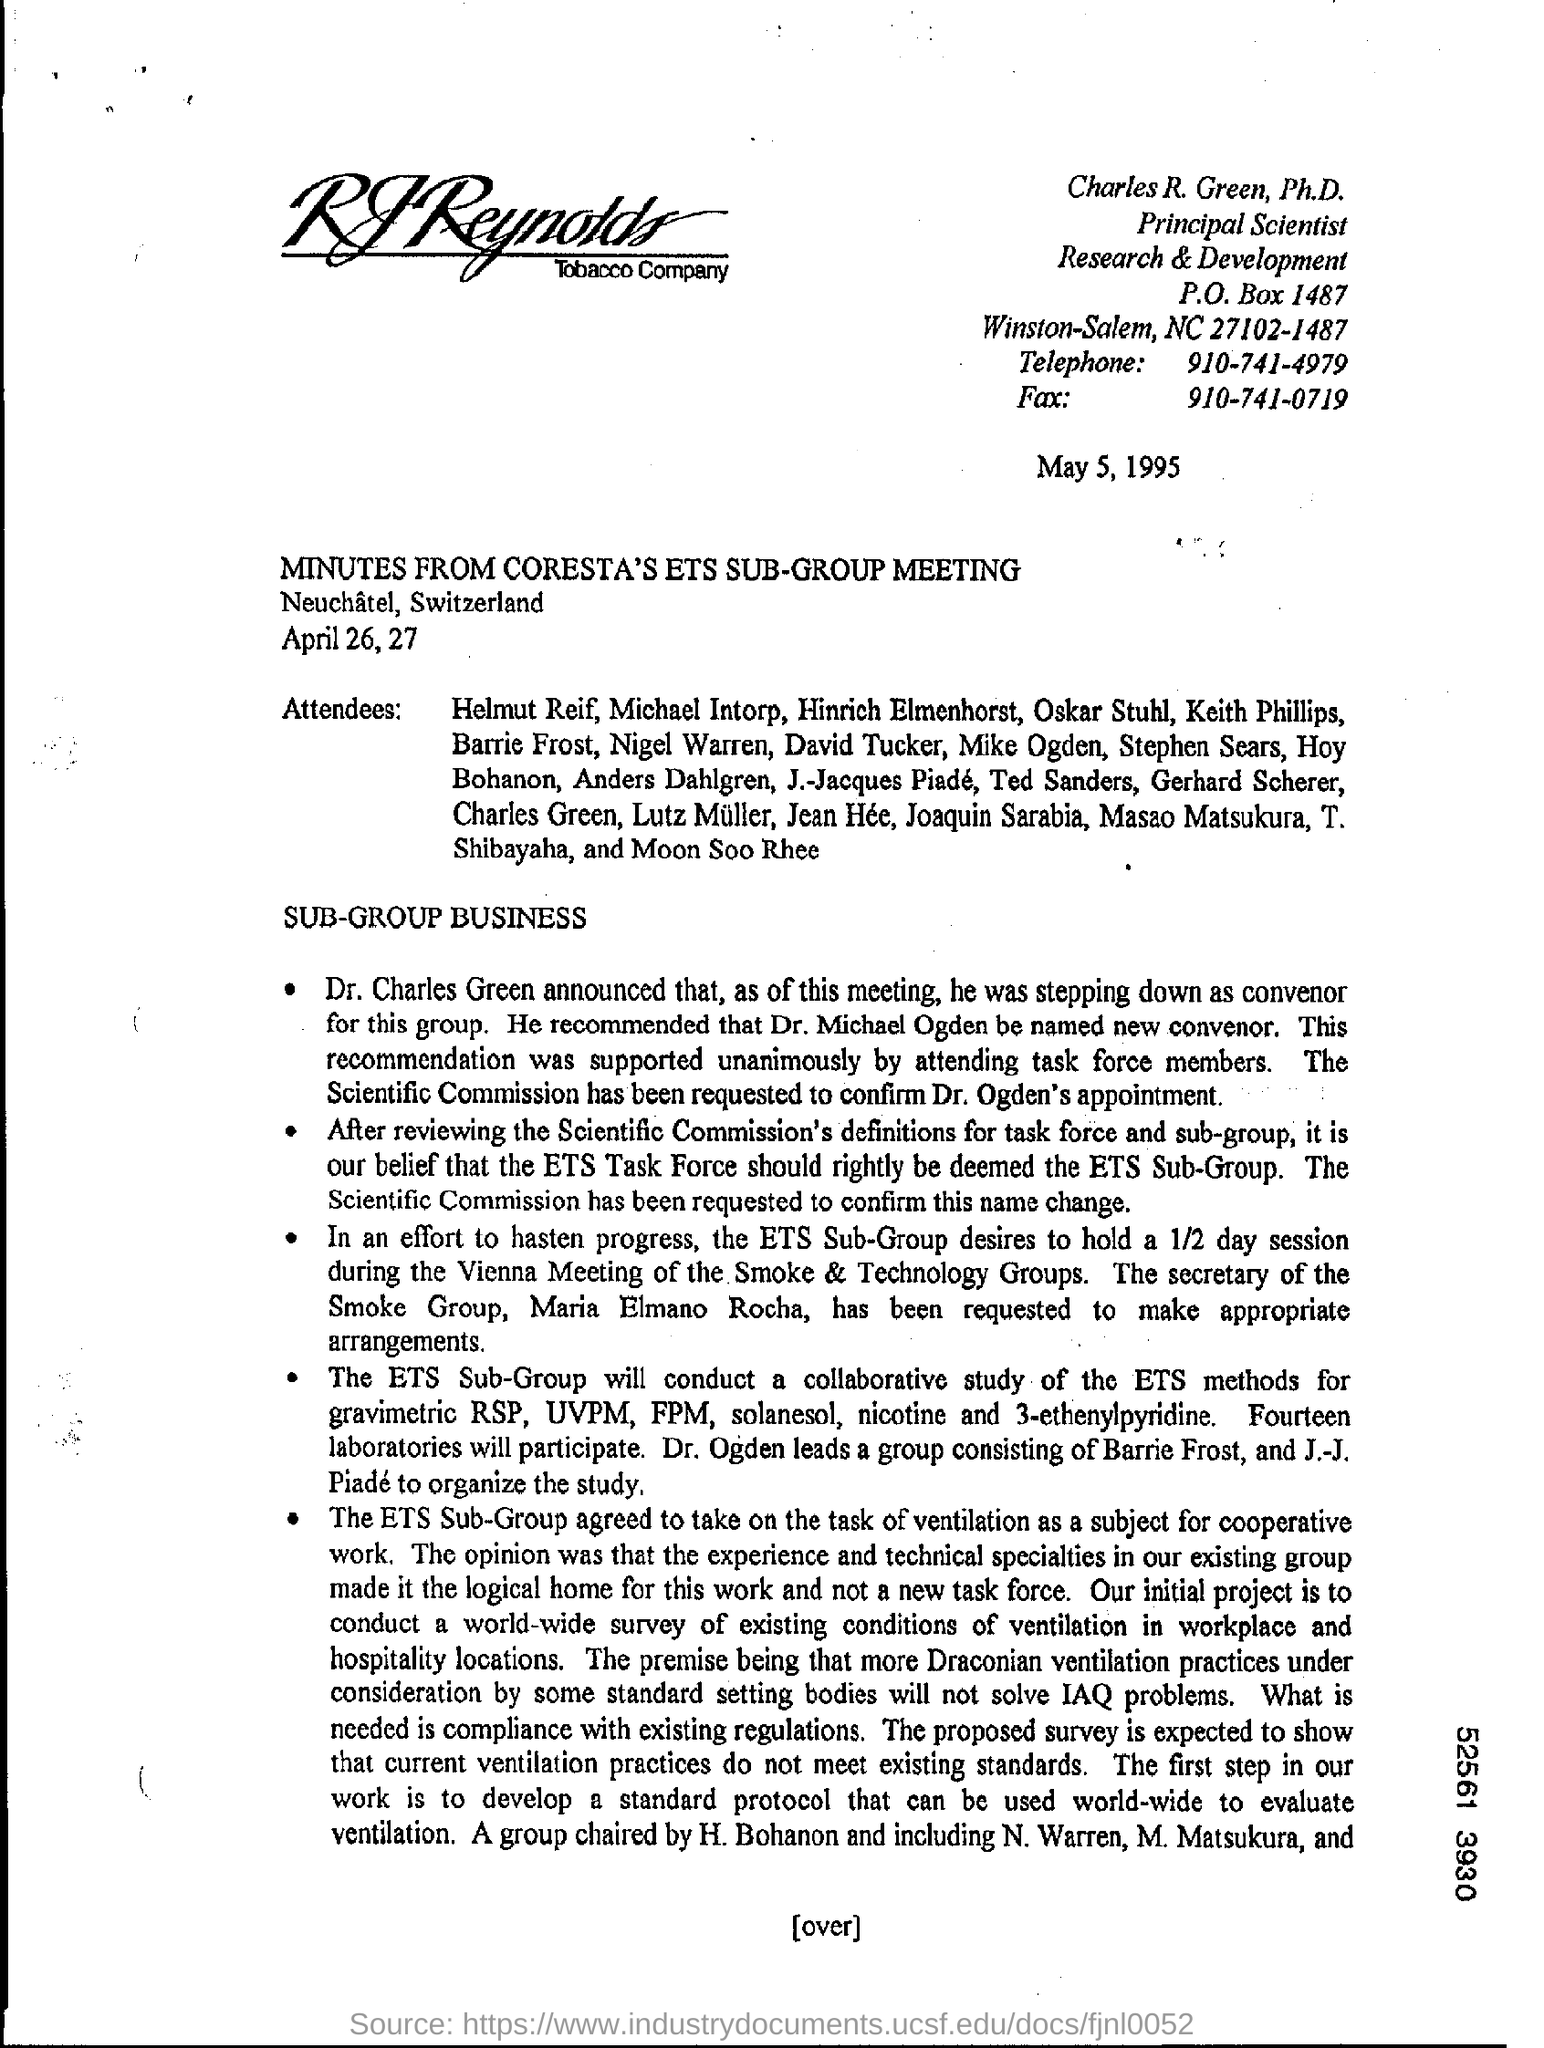List a handful of essential elements in this visual. The fax number is 910-741-0719. The telephone number is 910-741-4979. The P.O box number is 1487. 